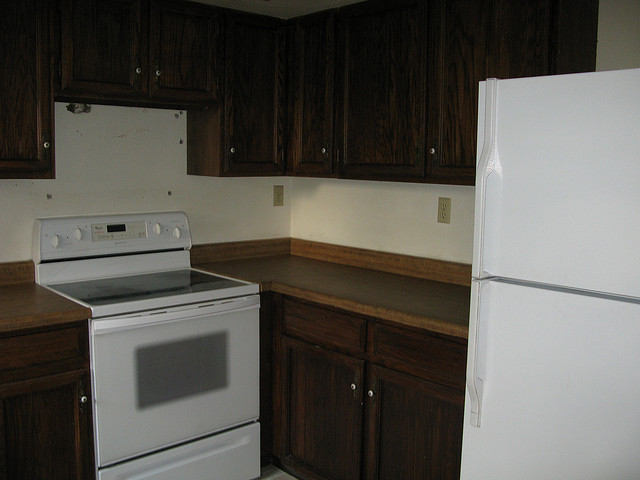<image>Where is the phone? There is no phone visible in the image. Where is the phone? I don't know where the phone is. It can be in the den, bedroom, or somewhere else. 